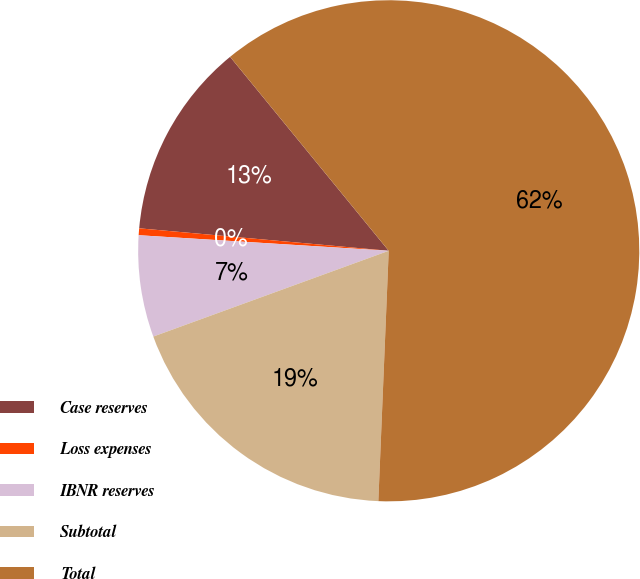<chart> <loc_0><loc_0><loc_500><loc_500><pie_chart><fcel>Case reserves<fcel>Loss expenses<fcel>IBNR reserves<fcel>Subtotal<fcel>Total<nl><fcel>12.66%<fcel>0.44%<fcel>6.55%<fcel>18.78%<fcel>61.57%<nl></chart> 